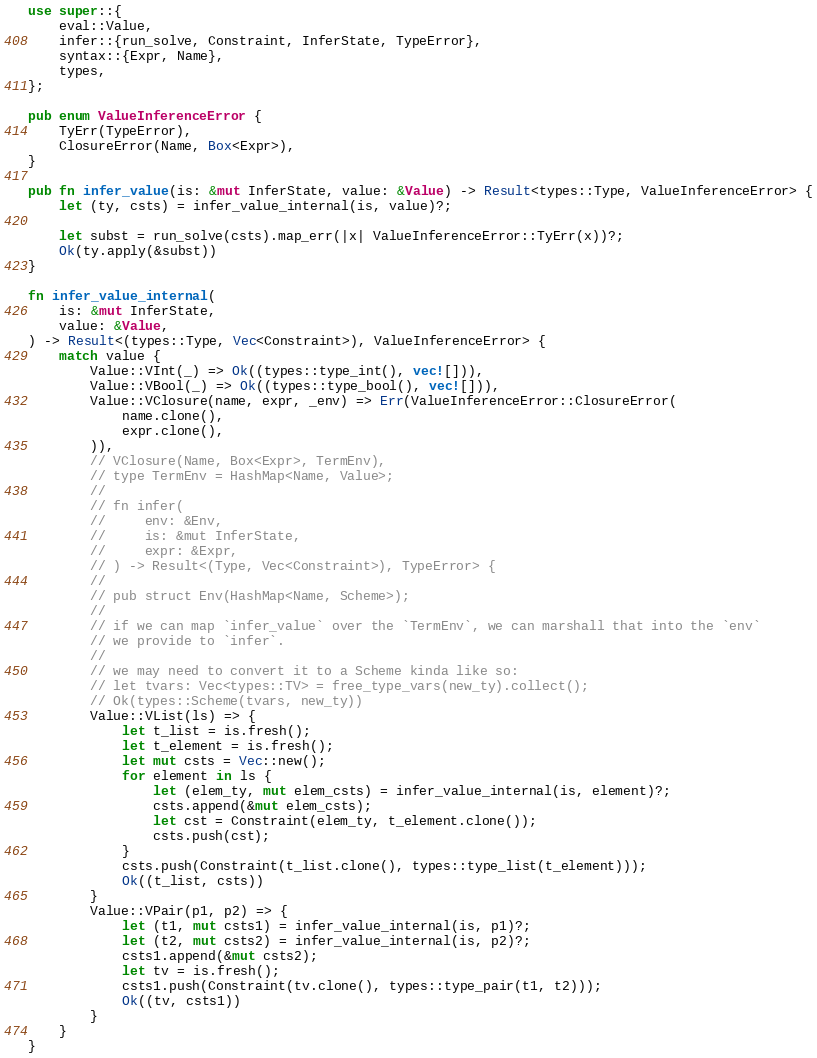<code> <loc_0><loc_0><loc_500><loc_500><_Rust_>use super::{
    eval::Value,
    infer::{run_solve, Constraint, InferState, TypeError},
    syntax::{Expr, Name},
    types,
};

pub enum ValueInferenceError {
    TyErr(TypeError),
    ClosureError(Name, Box<Expr>),
}

pub fn infer_value(is: &mut InferState, value: &Value) -> Result<types::Type, ValueInferenceError> {
    let (ty, csts) = infer_value_internal(is, value)?;

    let subst = run_solve(csts).map_err(|x| ValueInferenceError::TyErr(x))?;
    Ok(ty.apply(&subst))
}

fn infer_value_internal(
    is: &mut InferState,
    value: &Value,
) -> Result<(types::Type, Vec<Constraint>), ValueInferenceError> {
    match value {
        Value::VInt(_) => Ok((types::type_int(), vec![])),
        Value::VBool(_) => Ok((types::type_bool(), vec![])),
        Value::VClosure(name, expr, _env) => Err(ValueInferenceError::ClosureError(
            name.clone(),
            expr.clone(),
        )),
        // VClosure(Name, Box<Expr>, TermEnv),
        // type TermEnv = HashMap<Name, Value>;
        //
        // fn infer(
        //     env: &Env,
        //     is: &mut InferState,
        //     expr: &Expr,
        // ) -> Result<(Type, Vec<Constraint>), TypeError> {
        //
        // pub struct Env(HashMap<Name, Scheme>);
        //
        // if we can map `infer_value` over the `TermEnv`, we can marshall that into the `env`
        // we provide to `infer`.
        //
        // we may need to convert it to a Scheme kinda like so:
        // let tvars: Vec<types::TV> = free_type_vars(new_ty).collect();
        // Ok(types::Scheme(tvars, new_ty))
        Value::VList(ls) => {
            let t_list = is.fresh();
            let t_element = is.fresh();
            let mut csts = Vec::new();
            for element in ls {
                let (elem_ty, mut elem_csts) = infer_value_internal(is, element)?;
                csts.append(&mut elem_csts);
                let cst = Constraint(elem_ty, t_element.clone());
                csts.push(cst);
            }
            csts.push(Constraint(t_list.clone(), types::type_list(t_element)));
            Ok((t_list, csts))
        }
        Value::VPair(p1, p2) => {
            let (t1, mut csts1) = infer_value_internal(is, p1)?;
            let (t2, mut csts2) = infer_value_internal(is, p2)?;
            csts1.append(&mut csts2);
            let tv = is.fresh();
            csts1.push(Constraint(tv.clone(), types::type_pair(t1, t2)));
            Ok((tv, csts1))
        }
    }
}
</code> 